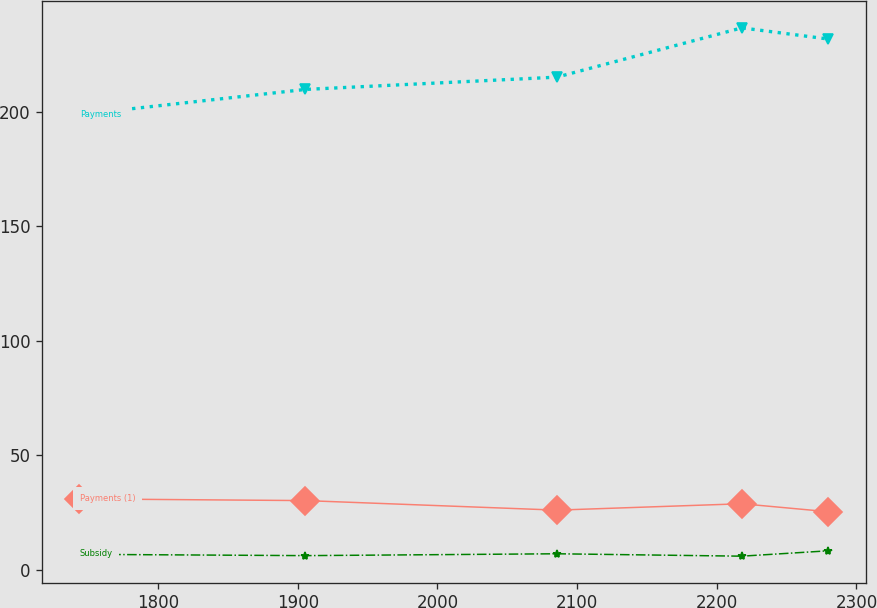<chart> <loc_0><loc_0><loc_500><loc_500><line_chart><ecel><fcel>Payments<fcel>Payments (1)<fcel>Subsidy<nl><fcel>1743.7<fcel>198.81<fcel>30.95<fcel>6.73<nl><fcel>1905.42<fcel>209.78<fcel>30.2<fcel>6.16<nl><fcel>2085.53<fcel>215.15<fcel>26.03<fcel>6.97<nl><fcel>2217.88<fcel>236.67<fcel>28.82<fcel>5.92<nl><fcel>2279.88<fcel>231.79<fcel>25.34<fcel>8.27<nl></chart> 